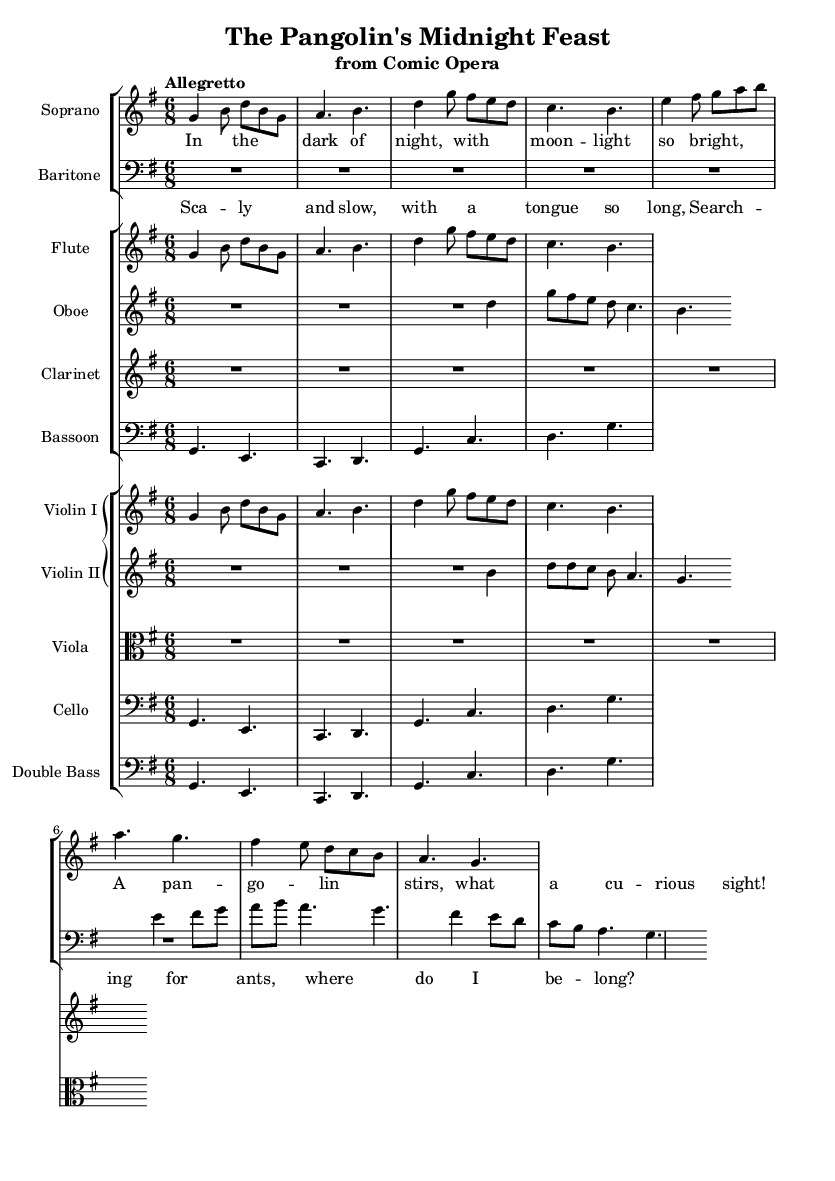What is the key signature of this music? The key signature is G major, which has one sharp (F#) indicated at the beginning of the staff.
Answer: G major What is the time signature of this music? The time signature is 6/8, which is shown as a fraction at the beginning of the score.
Answer: 6/8 What is the tempo marking for this piece? The tempo marking is "Allegretto," indicating a moderately fast pace, often suitable for lively music.
Answer: Allegretto How many voices are featured in the opera section? There are two voices featured: Soprano and Baritone, each indicated on separate staves.
Answer: Two What is the starting note of the Soprano part? The starting note of the Soprano part is G, which is the first note in the relative pitch notation.
Answer: G How many instruments are in the ensemble? There are a total of seven different instrumental parts indicated in the score, including flute, oboe, clarinet, bassoon, and strings.
Answer: Seven What theme is depicted in the lyrics of the opera? The theme depicted in the lyrics revolves around the daily life and curiosity of a pangolin, as suggested by the content of the lyrics.
Answer: Pangolin's curiosity 